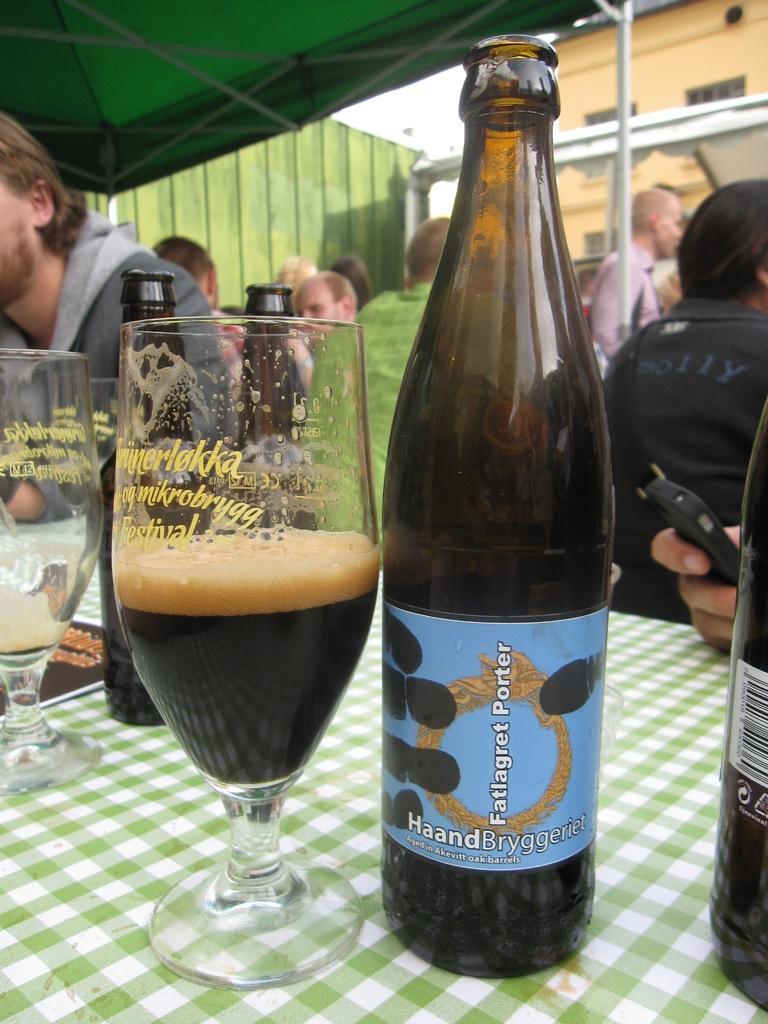Can you describe this image briefly? In this picture we can see a group of people sitting and in front we have glass with drink in it, bottle and this are on a table and in background we can see wall, umbrella. 